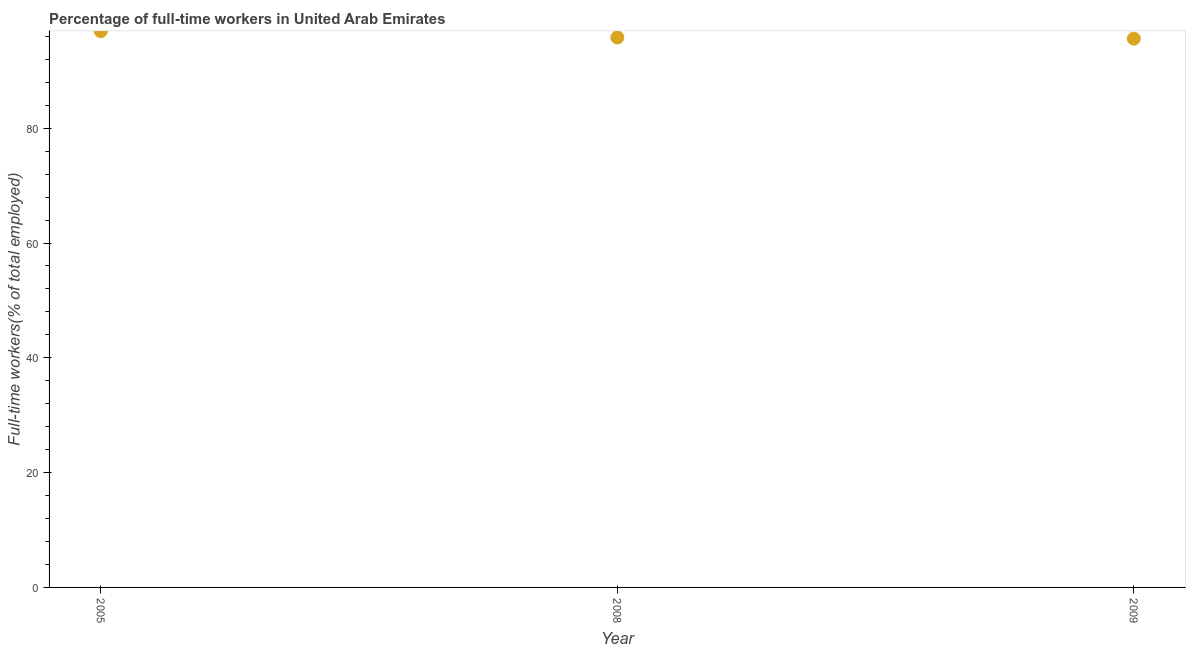What is the percentage of full-time workers in 2008?
Offer a terse response. 95.8. Across all years, what is the maximum percentage of full-time workers?
Offer a terse response. 96.9. Across all years, what is the minimum percentage of full-time workers?
Your answer should be compact. 95.6. What is the sum of the percentage of full-time workers?
Ensure brevity in your answer.  288.3. What is the difference between the percentage of full-time workers in 2005 and 2008?
Give a very brief answer. 1.1. What is the average percentage of full-time workers per year?
Provide a short and direct response. 96.1. What is the median percentage of full-time workers?
Offer a very short reply. 95.8. Do a majority of the years between 2009 and 2008 (inclusive) have percentage of full-time workers greater than 36 %?
Ensure brevity in your answer.  No. What is the ratio of the percentage of full-time workers in 2008 to that in 2009?
Ensure brevity in your answer.  1. What is the difference between the highest and the second highest percentage of full-time workers?
Provide a succinct answer. 1.1. Is the sum of the percentage of full-time workers in 2005 and 2009 greater than the maximum percentage of full-time workers across all years?
Your response must be concise. Yes. What is the difference between the highest and the lowest percentage of full-time workers?
Provide a short and direct response. 1.3. In how many years, is the percentage of full-time workers greater than the average percentage of full-time workers taken over all years?
Provide a short and direct response. 1. How many years are there in the graph?
Give a very brief answer. 3. Are the values on the major ticks of Y-axis written in scientific E-notation?
Ensure brevity in your answer.  No. Does the graph contain any zero values?
Offer a terse response. No. What is the title of the graph?
Your answer should be compact. Percentage of full-time workers in United Arab Emirates. What is the label or title of the X-axis?
Provide a short and direct response. Year. What is the label or title of the Y-axis?
Your response must be concise. Full-time workers(% of total employed). What is the Full-time workers(% of total employed) in 2005?
Give a very brief answer. 96.9. What is the Full-time workers(% of total employed) in 2008?
Offer a very short reply. 95.8. What is the Full-time workers(% of total employed) in 2009?
Make the answer very short. 95.6. What is the difference between the Full-time workers(% of total employed) in 2005 and 2008?
Your answer should be very brief. 1.1. 